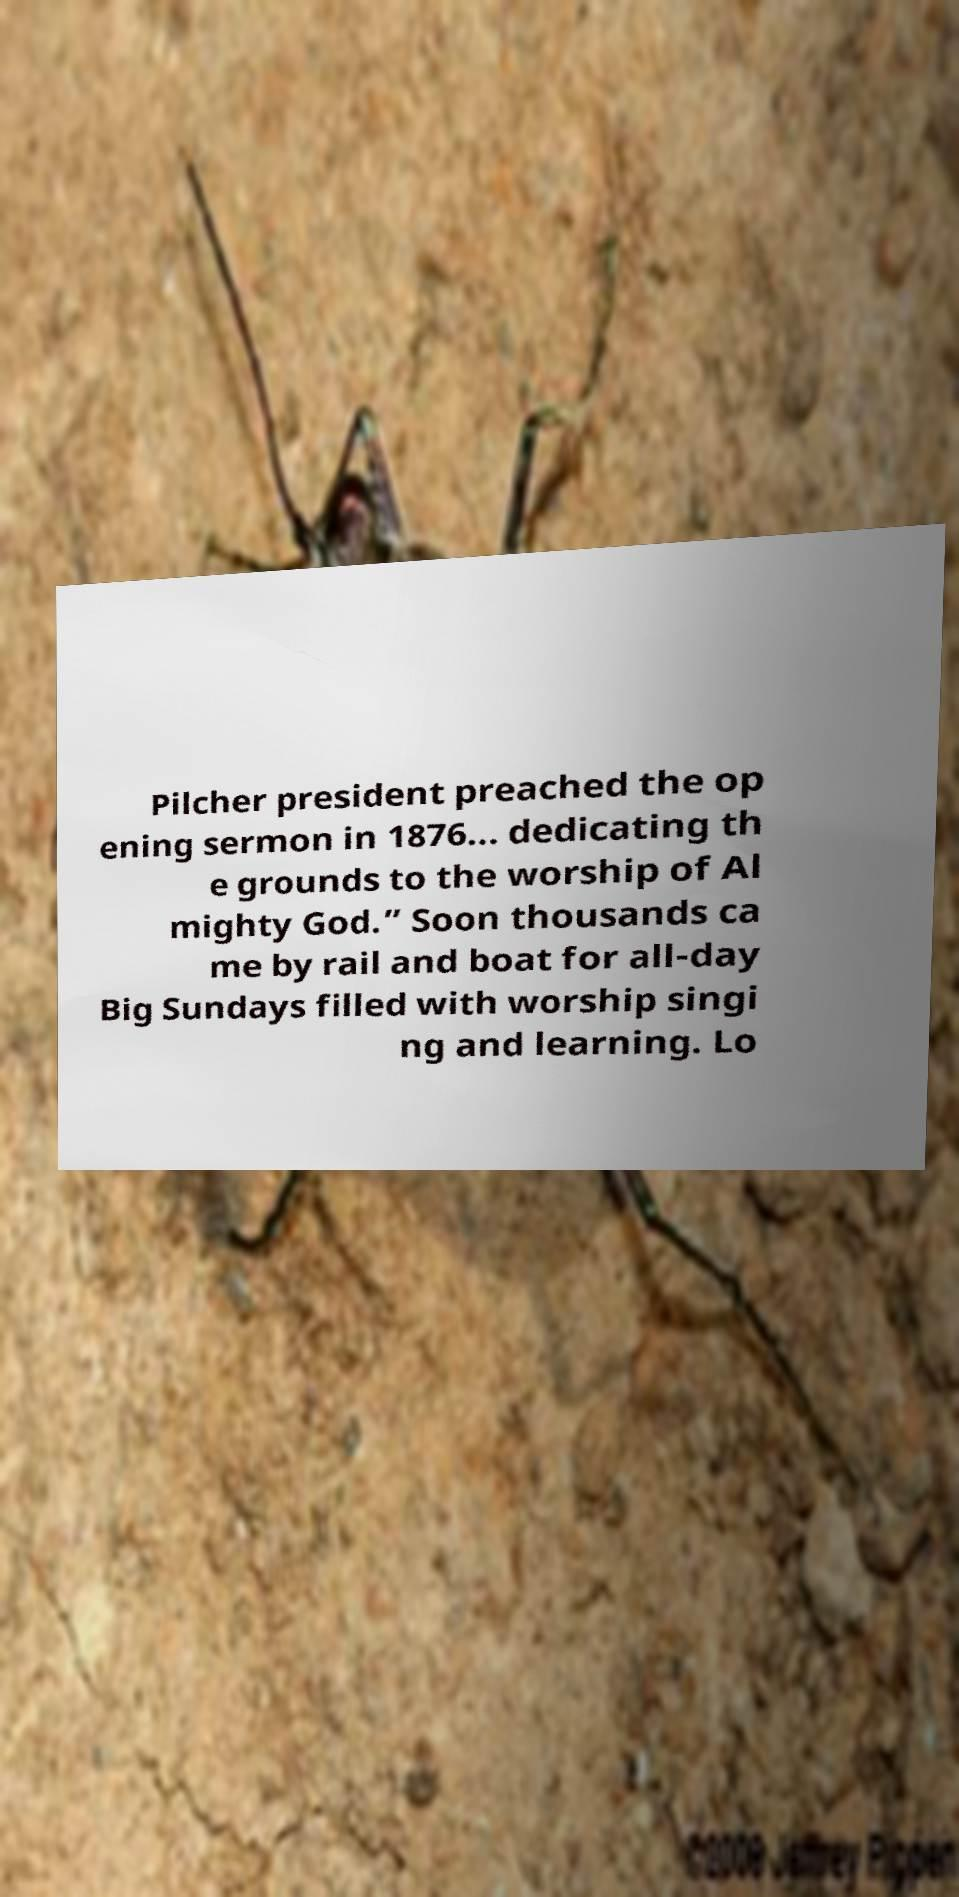There's text embedded in this image that I need extracted. Can you transcribe it verbatim? Pilcher president preached the op ening sermon in 1876... dedicating th e grounds to the worship of Al mighty God.” Soon thousands ca me by rail and boat for all-day Big Sundays filled with worship singi ng and learning. Lo 